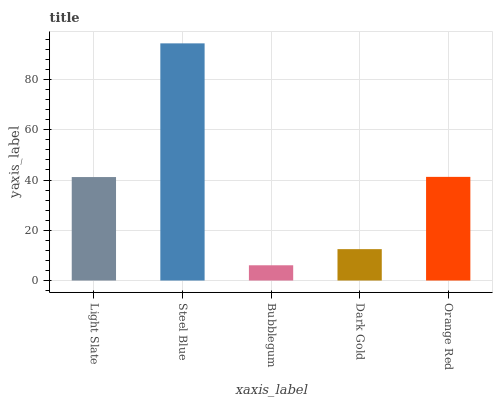Is Bubblegum the minimum?
Answer yes or no. Yes. Is Steel Blue the maximum?
Answer yes or no. Yes. Is Steel Blue the minimum?
Answer yes or no. No. Is Bubblegum the maximum?
Answer yes or no. No. Is Steel Blue greater than Bubblegum?
Answer yes or no. Yes. Is Bubblegum less than Steel Blue?
Answer yes or no. Yes. Is Bubblegum greater than Steel Blue?
Answer yes or no. No. Is Steel Blue less than Bubblegum?
Answer yes or no. No. Is Light Slate the high median?
Answer yes or no. Yes. Is Light Slate the low median?
Answer yes or no. Yes. Is Orange Red the high median?
Answer yes or no. No. Is Dark Gold the low median?
Answer yes or no. No. 